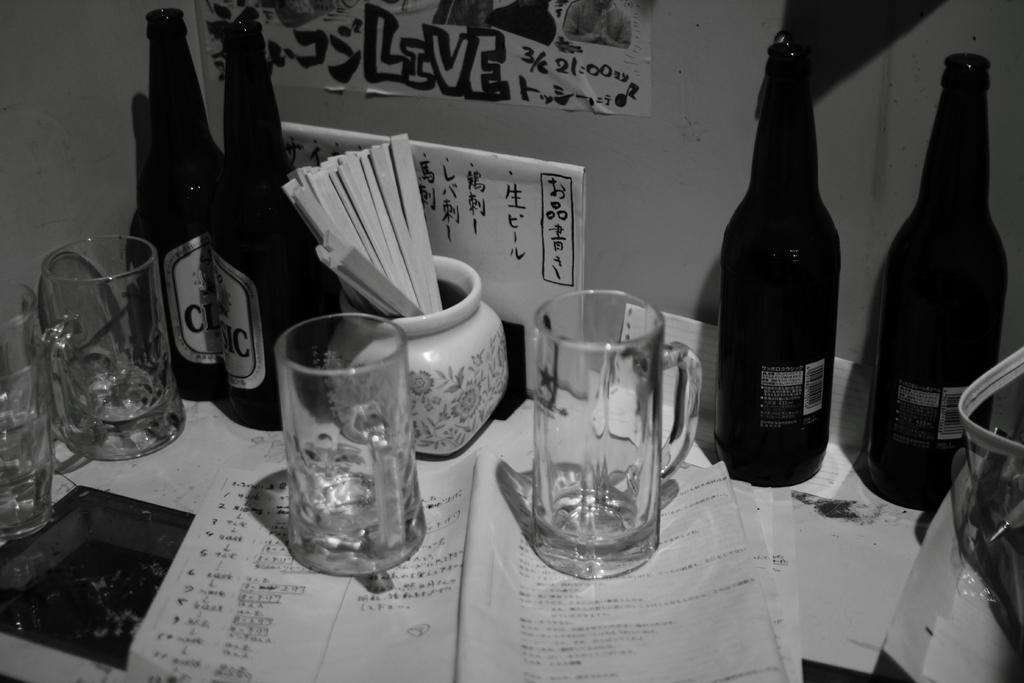Could you give a brief overview of what you see in this image? In this image there are a group of bottles and glasses and one pot is there, and on the bottom there are some papers. And on the background there is a wall and on that wall there are some posters. On the bottom of the right corner there is one plastic bag. 